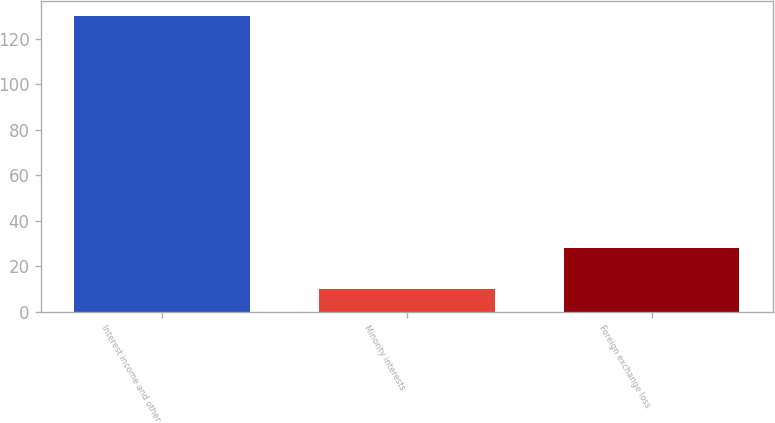<chart> <loc_0><loc_0><loc_500><loc_500><bar_chart><fcel>Interest income and other<fcel>Minority interests<fcel>Foreign exchange loss<nl><fcel>130<fcel>10<fcel>28<nl></chart> 